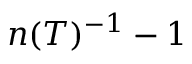Convert formula to latex. <formula><loc_0><loc_0><loc_500><loc_500>n ( T ) ^ { - 1 } - 1</formula> 